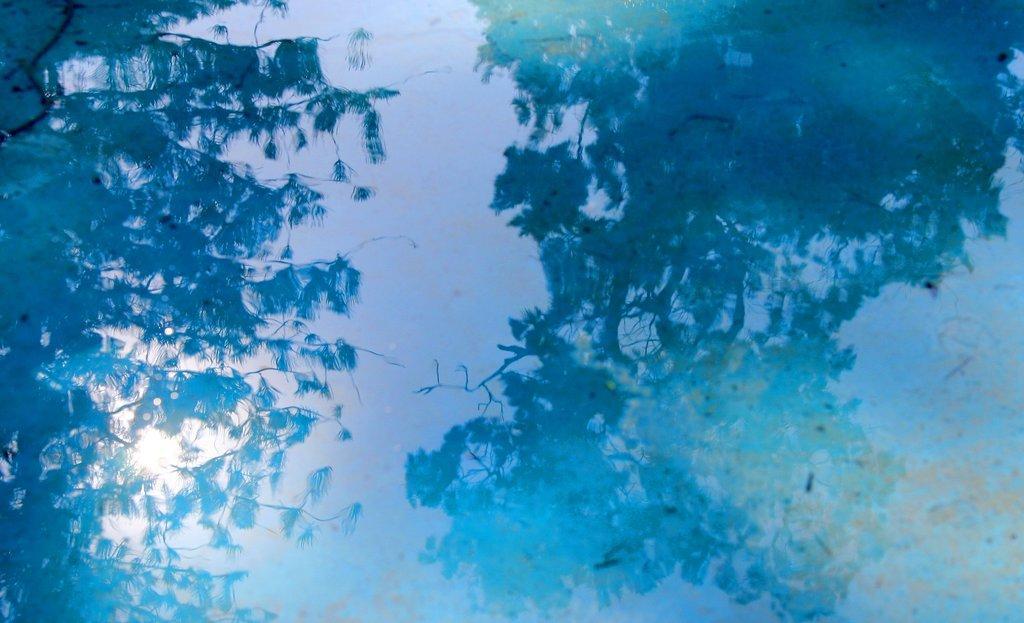In one or two sentences, can you explain what this image depicts? This picture look like painting. In the water reflection we can see sky, tree and sun. 